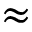Convert formula to latex. <formula><loc_0><loc_0><loc_500><loc_500>\approx</formula> 